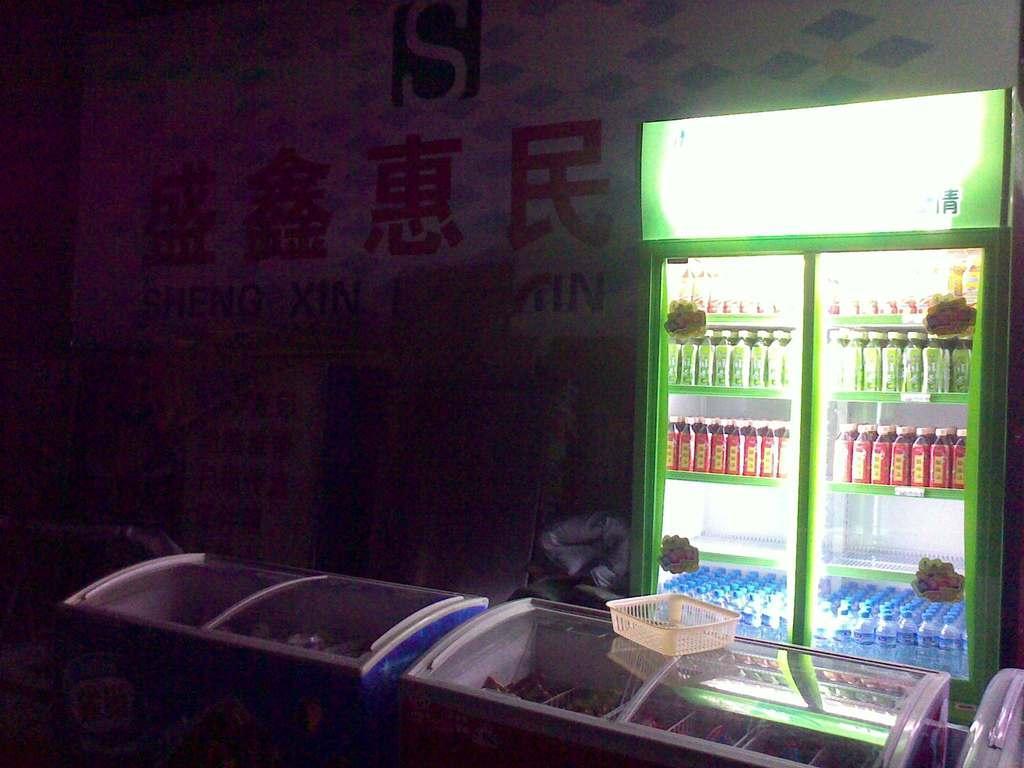How would you summarize this image in a sentence or two? In this image there is a refrigerator in which there are bottles. At the bottom there are fridges one beside the other. Above the fridge there is a tray. In the background there is a banner. 